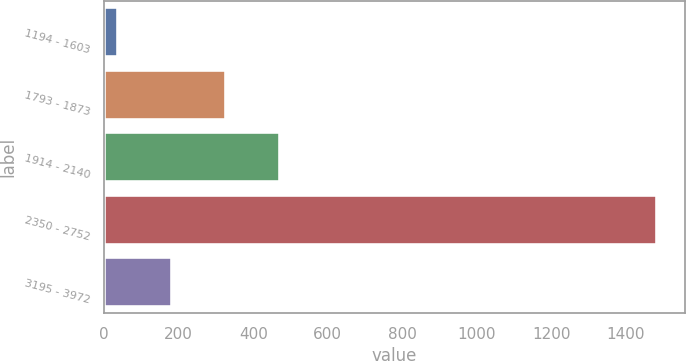Convert chart to OTSL. <chart><loc_0><loc_0><loc_500><loc_500><bar_chart><fcel>1194 - 1603<fcel>1793 - 1873<fcel>1914 - 2140<fcel>2350 - 2752<fcel>3195 - 3972<nl><fcel>37<fcel>326.4<fcel>471.1<fcel>1484<fcel>181.7<nl></chart> 